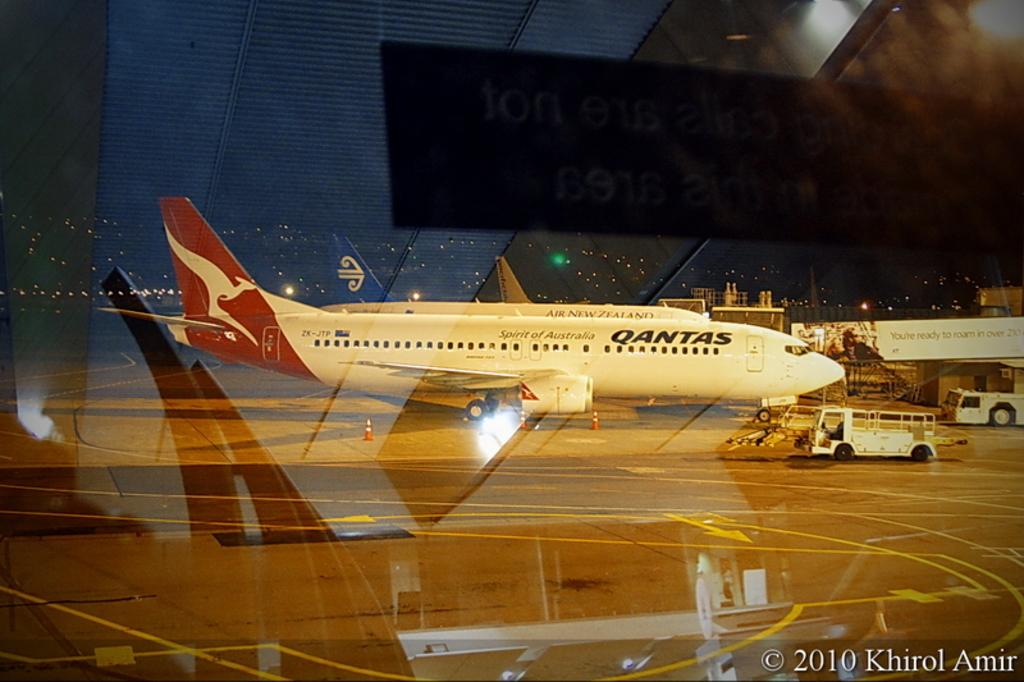What country name is displayed on the jet?
Offer a very short reply. Australia. When was this photo printed?
Offer a very short reply. 2010. 